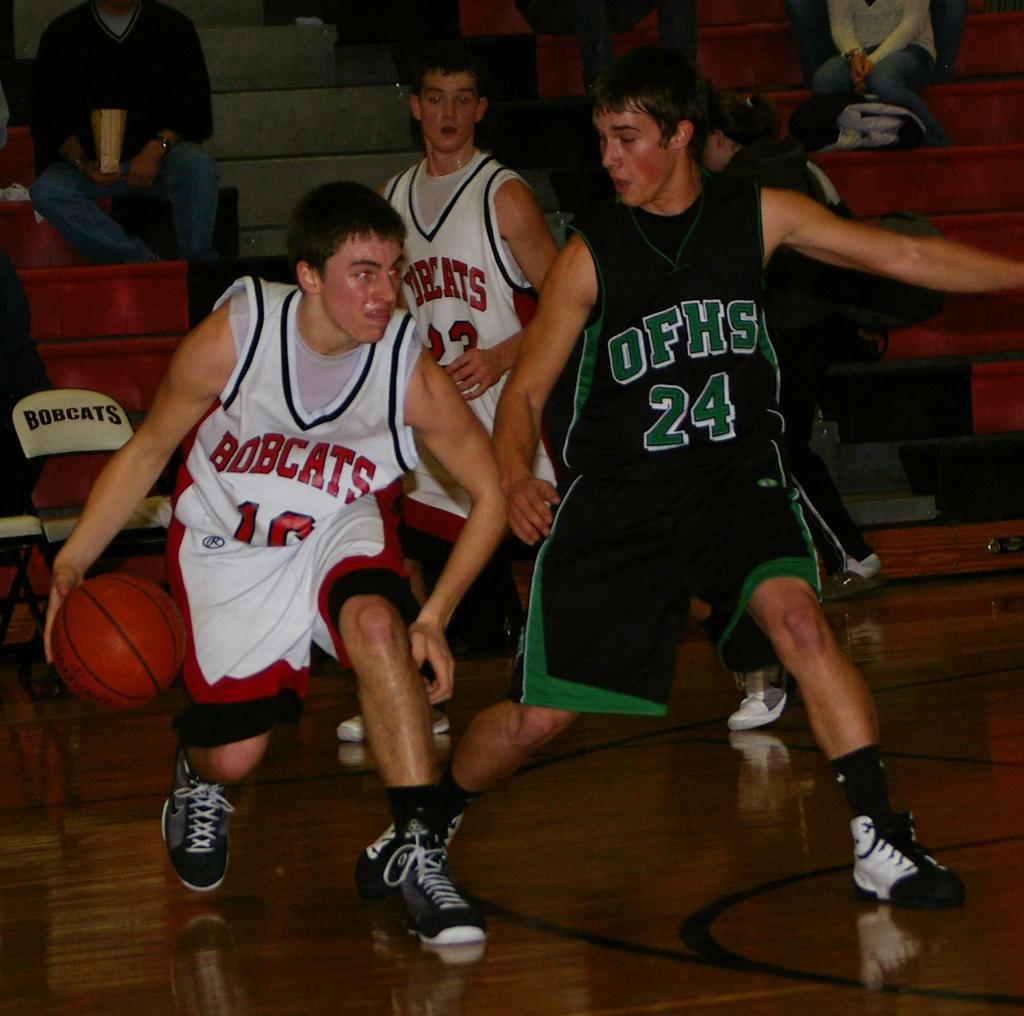Provide a one-sentence caption for the provided image. Number 24 of OFHS plays defense against the Bobcats team. 